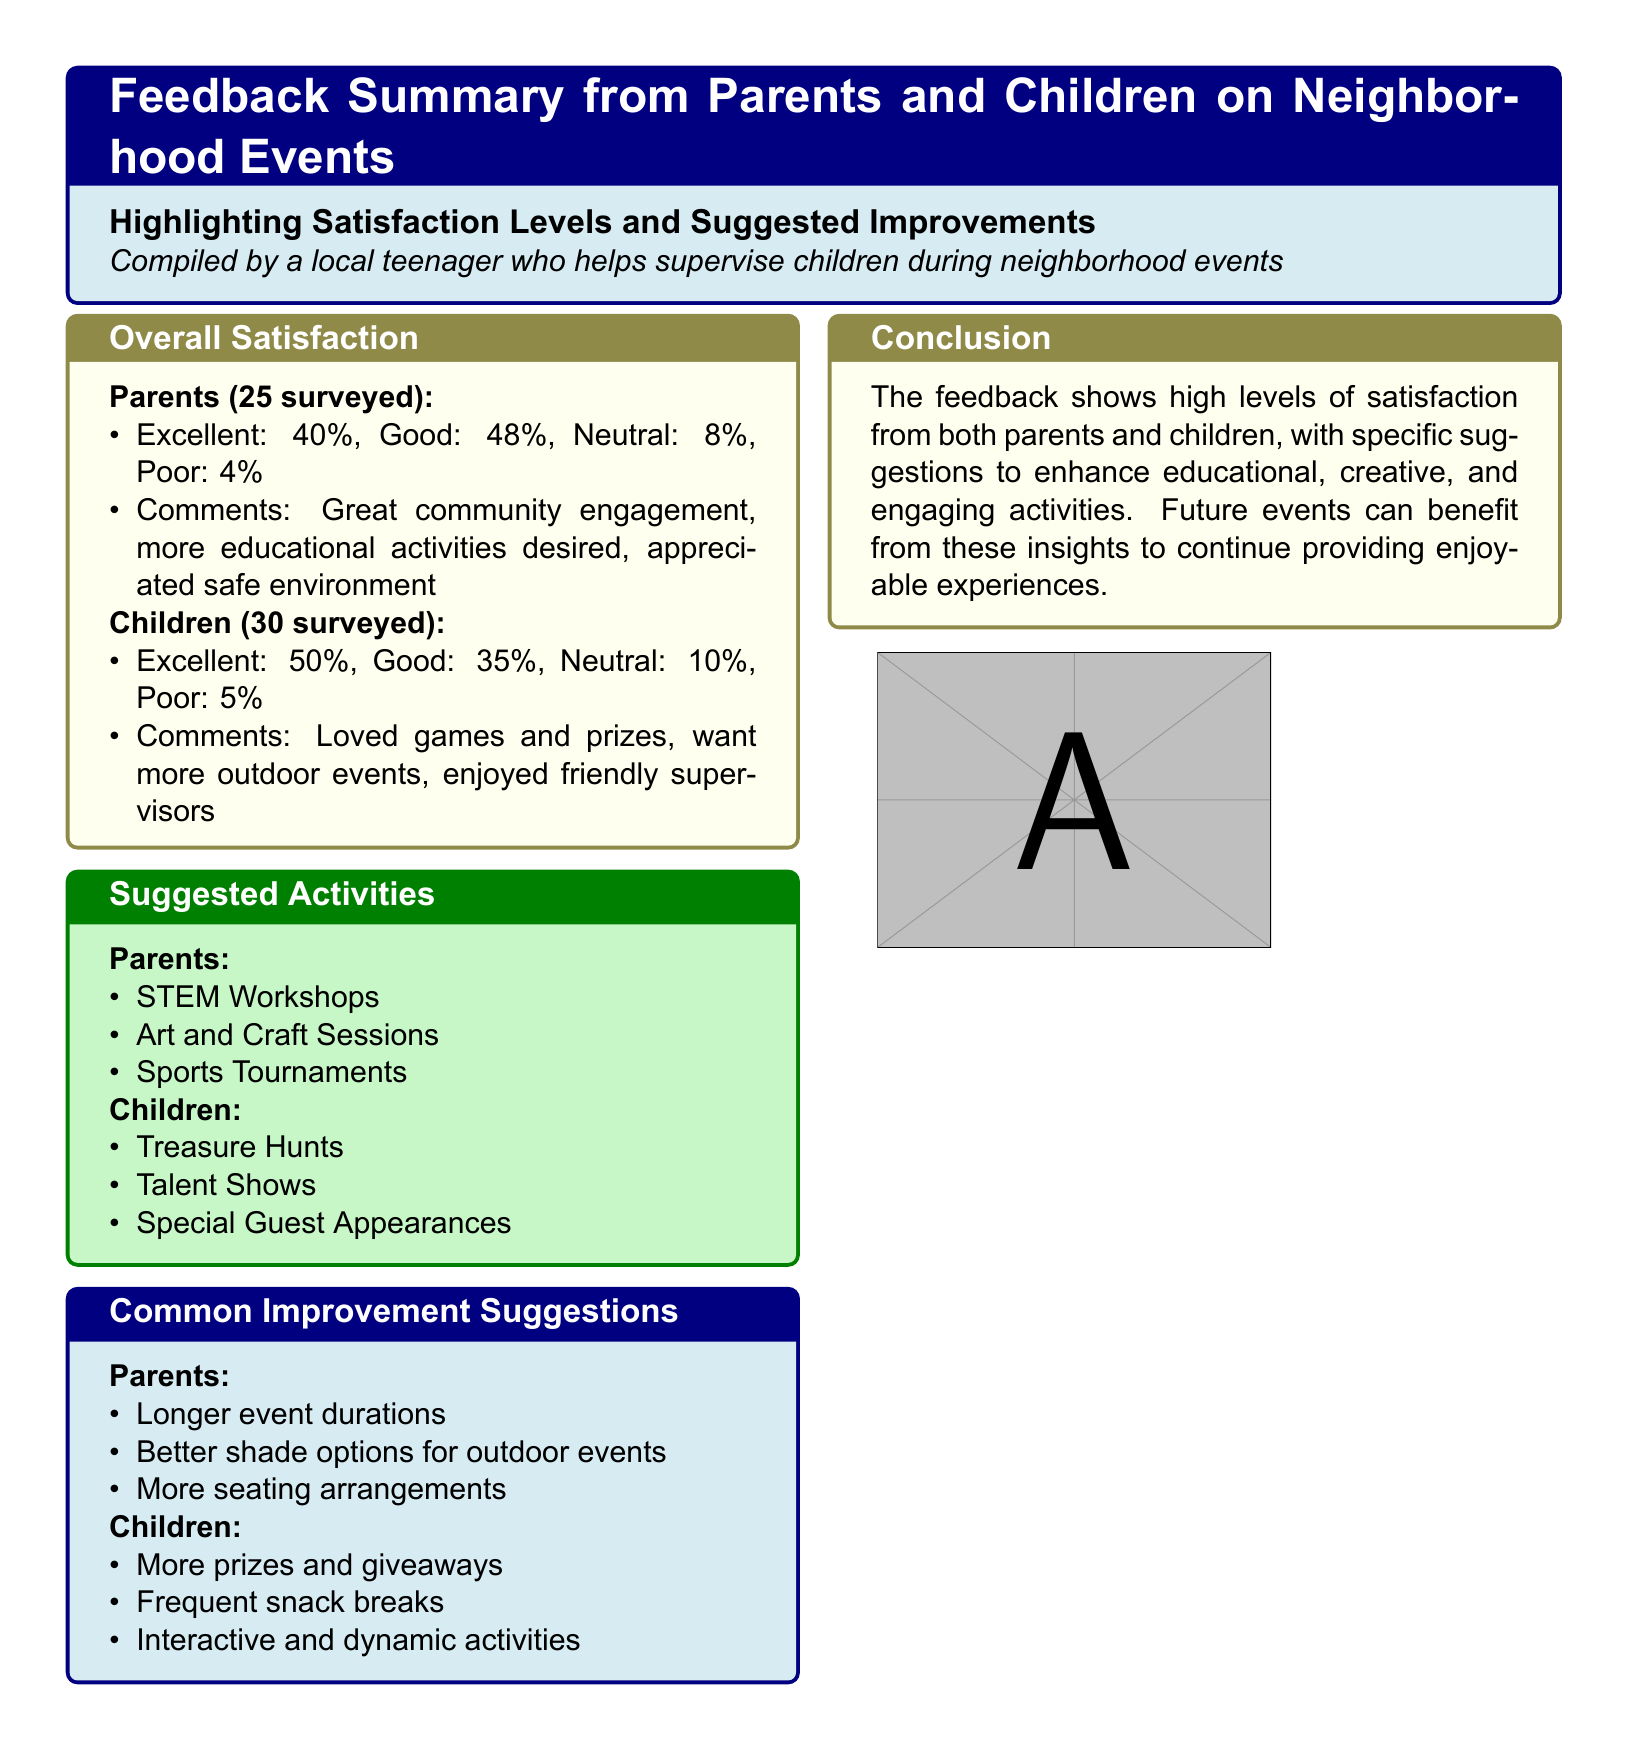What percentage of parents rated the event as excellent? The document states that 40% of parents surveyed rated the event as excellent.
Answer: 40% What did 50% of children think about the event? The document indicates that 50% of children surveyed rated the event as excellent.
Answer: Excellent What activity did parents suggest for future events? The document lists STEM Workshops as one of the suggested activities by parents.
Answer: STEM Workshops What is the total number of parents surveyed? The document notes that 25 parents were surveyed for the feedback summary.
Answer: 25 What was one common improvement suggestion from children? The document mentions "more prizes and giveaways" as a common improvement suggestion from children.
Answer: More prizes and giveaways What percentage of children reported a poor experience? According to the document, 5% of children rated their experience as poor.
Answer: 5% What overall satisfaction category did parents give the highest percentage? The document shows that Good received the highest percentage from parents, at 48%.
Answer: Good What type of events do children want more of? The document mentions that children want more outdoor events in their feedback.
Answer: Outdoor events What is a conclusion drawn from the feedback? The document concludes that the feedback shows high levels of satisfaction from both parents and children.
Answer: High levels of satisfaction 